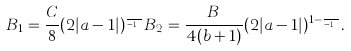Convert formula to latex. <formula><loc_0><loc_0><loc_500><loc_500>B _ { 1 } = \frac { C } { 8 } ( 2 | a - 1 | ) ^ { \frac { a } { a - 1 } } B _ { 2 } = \frac { B } { 4 ( b + 1 ) } ( 2 | a - 1 | ) ^ { 1 - \frac { b } { a - 1 } } .</formula> 